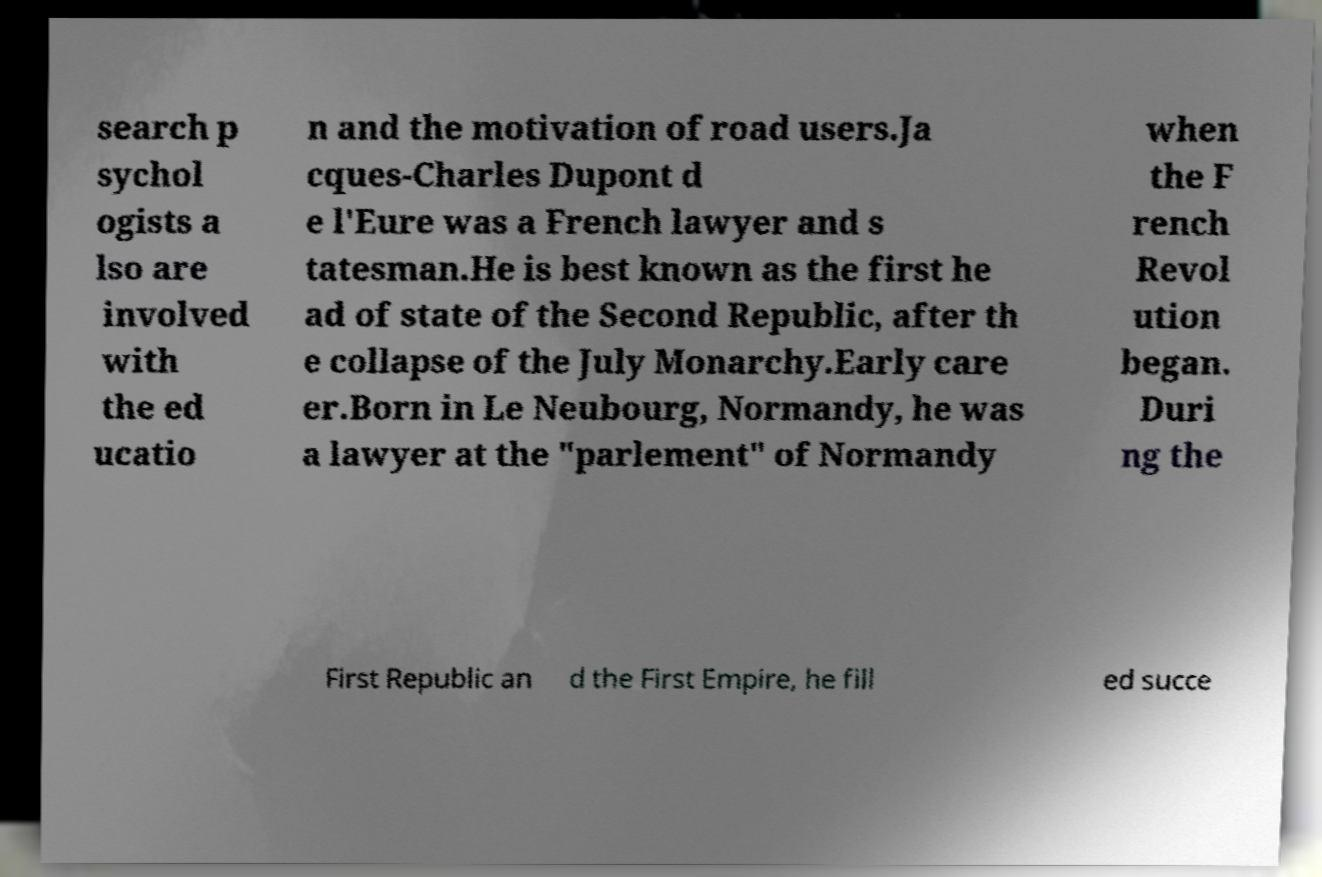What messages or text are displayed in this image? I need them in a readable, typed format. search p sychol ogists a lso are involved with the ed ucatio n and the motivation of road users.Ja cques-Charles Dupont d e l'Eure was a French lawyer and s tatesman.He is best known as the first he ad of state of the Second Republic, after th e collapse of the July Monarchy.Early care er.Born in Le Neubourg, Normandy, he was a lawyer at the "parlement" of Normandy when the F rench Revol ution began. Duri ng the First Republic an d the First Empire, he fill ed succe 